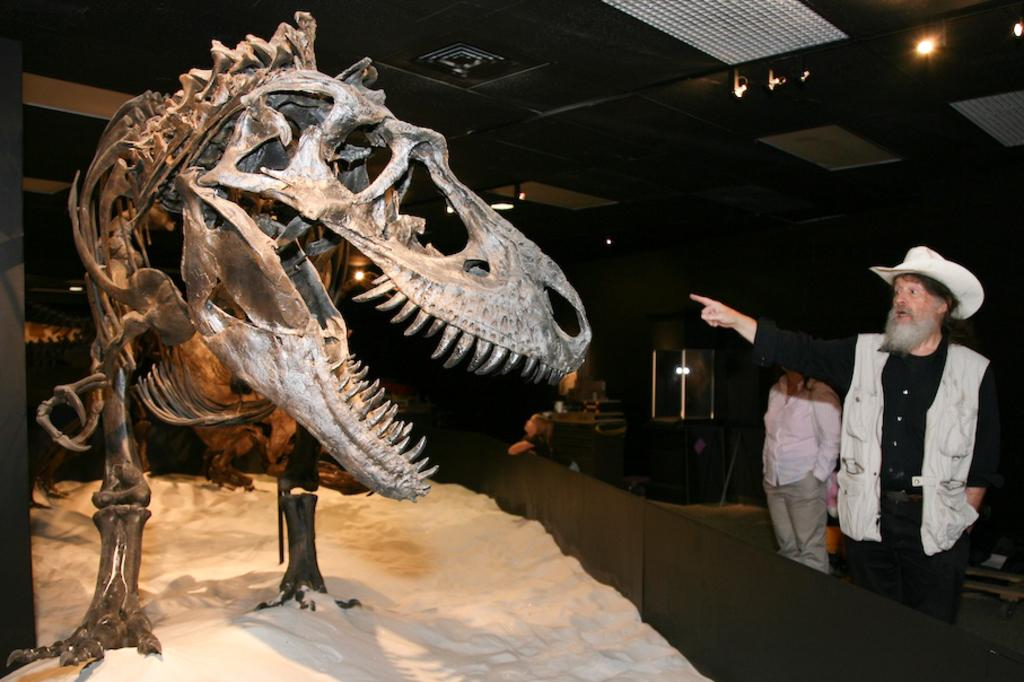What is the main subject of the image? There is a dinosaur skeleton in the image. How many people are present in the image? There are two persons standing in the image. What can be seen in the background of the image? There are objects visible in the background of the image. What type of illumination is present in the image? There are lights visible in the image. How many apples are being held by the stranger in the image? There is no stranger present in the image, and therefore no apples can be held by them. 